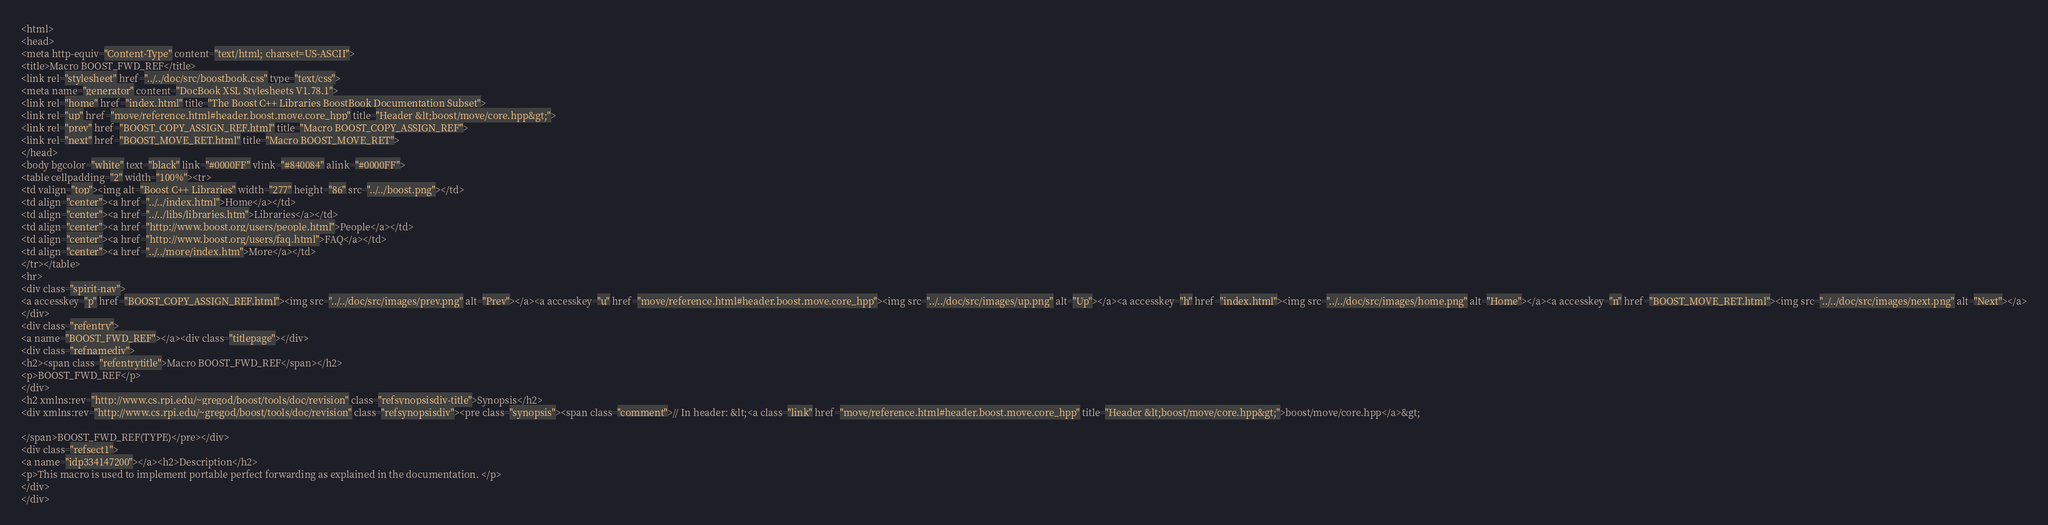<code> <loc_0><loc_0><loc_500><loc_500><_HTML_><html>
<head>
<meta http-equiv="Content-Type" content="text/html; charset=US-ASCII">
<title>Macro BOOST_FWD_REF</title>
<link rel="stylesheet" href="../../doc/src/boostbook.css" type="text/css">
<meta name="generator" content="DocBook XSL Stylesheets V1.78.1">
<link rel="home" href="index.html" title="The Boost C++ Libraries BoostBook Documentation Subset">
<link rel="up" href="move/reference.html#header.boost.move.core_hpp" title="Header &lt;boost/move/core.hpp&gt;">
<link rel="prev" href="BOOST_COPY_ASSIGN_REF.html" title="Macro BOOST_COPY_ASSIGN_REF">
<link rel="next" href="BOOST_MOVE_RET.html" title="Macro BOOST_MOVE_RET">
</head>
<body bgcolor="white" text="black" link="#0000FF" vlink="#840084" alink="#0000FF">
<table cellpadding="2" width="100%"><tr>
<td valign="top"><img alt="Boost C++ Libraries" width="277" height="86" src="../../boost.png"></td>
<td align="center"><a href="../../index.html">Home</a></td>
<td align="center"><a href="../../libs/libraries.htm">Libraries</a></td>
<td align="center"><a href="http://www.boost.org/users/people.html">People</a></td>
<td align="center"><a href="http://www.boost.org/users/faq.html">FAQ</a></td>
<td align="center"><a href="../../more/index.htm">More</a></td>
</tr></table>
<hr>
<div class="spirit-nav">
<a accesskey="p" href="BOOST_COPY_ASSIGN_REF.html"><img src="../../doc/src/images/prev.png" alt="Prev"></a><a accesskey="u" href="move/reference.html#header.boost.move.core_hpp"><img src="../../doc/src/images/up.png" alt="Up"></a><a accesskey="h" href="index.html"><img src="../../doc/src/images/home.png" alt="Home"></a><a accesskey="n" href="BOOST_MOVE_RET.html"><img src="../../doc/src/images/next.png" alt="Next"></a>
</div>
<div class="refentry">
<a name="BOOST_FWD_REF"></a><div class="titlepage"></div>
<div class="refnamediv">
<h2><span class="refentrytitle">Macro BOOST_FWD_REF</span></h2>
<p>BOOST_FWD_REF</p>
</div>
<h2 xmlns:rev="http://www.cs.rpi.edu/~gregod/boost/tools/doc/revision" class="refsynopsisdiv-title">Synopsis</h2>
<div xmlns:rev="http://www.cs.rpi.edu/~gregod/boost/tools/doc/revision" class="refsynopsisdiv"><pre class="synopsis"><span class="comment">// In header: &lt;<a class="link" href="move/reference.html#header.boost.move.core_hpp" title="Header &lt;boost/move/core.hpp&gt;">boost/move/core.hpp</a>&gt;

</span>BOOST_FWD_REF(TYPE)</pre></div>
<div class="refsect1">
<a name="idp334147200"></a><h2>Description</h2>
<p>This macro is used to implement portable perfect forwarding as explained in the documentation. </p>
</div>
</div></code> 